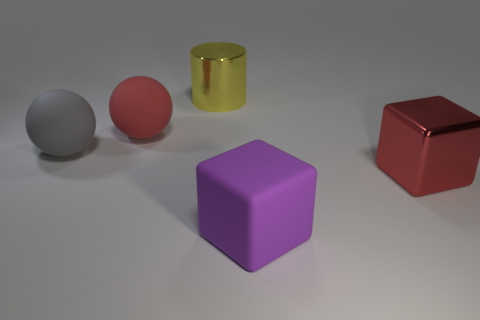Is the matte cube the same color as the cylinder?
Your response must be concise. No. There is a large matte thing that is to the right of the gray matte sphere and behind the large red block; what is its color?
Ensure brevity in your answer.  Red. Does the matte object behind the gray sphere have the same size as the large yellow shiny cylinder?
Your answer should be very brief. Yes. Is there anything else that has the same shape as the yellow thing?
Your answer should be very brief. No. Is the gray ball made of the same material as the big red thing right of the big yellow object?
Ensure brevity in your answer.  No. How many cyan things are either rubber cubes or matte cylinders?
Ensure brevity in your answer.  0. Are there any red matte balls?
Keep it short and to the point. Yes. Are there any metal objects behind the big object that is right of the purple block left of the big red metal thing?
Your answer should be very brief. Yes. There is a gray object; is its shape the same as the red object to the right of the large yellow object?
Your answer should be very brief. No. There is a rubber thing to the right of the large shiny thing that is behind the large object that is on the right side of the large purple rubber object; what is its color?
Keep it short and to the point. Purple. 